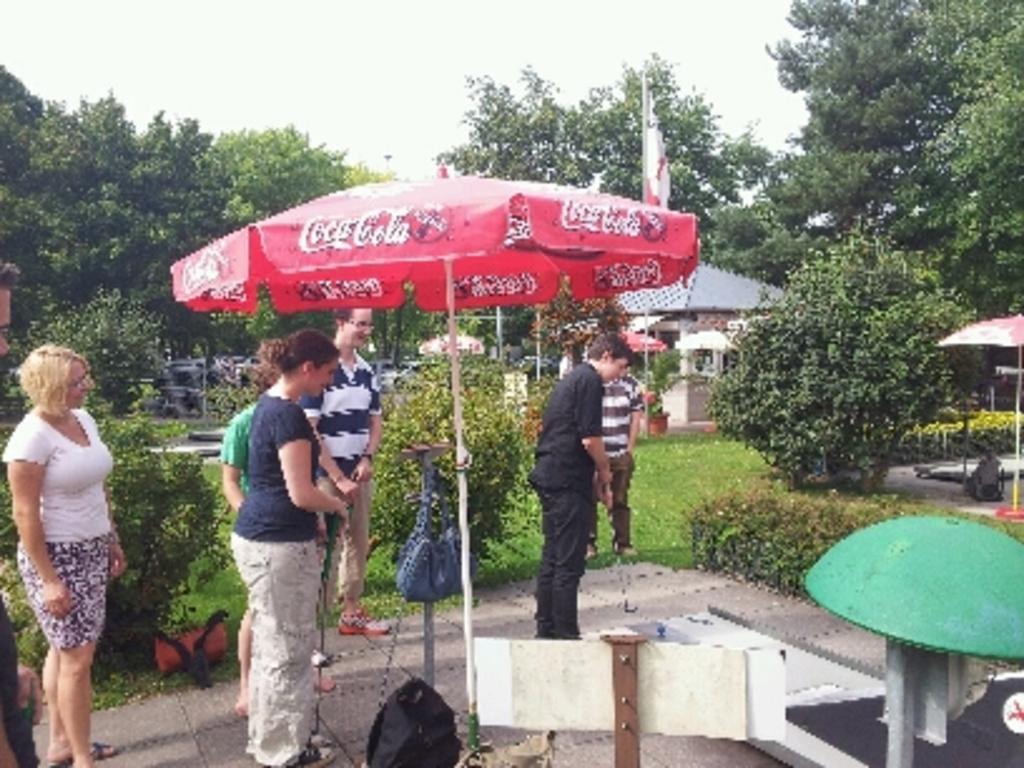Describe this image in one or two sentences. This picture consists of red color tent , under the tent I can see few persons and pole and bag attached to the pole and a luggage bag kept on floor at the bottom and I can see there are remaining persons standing in front of plants and trees and houses visible in the middle. in the background there are some vehicle and at the top I can see the sky and on the right side I can see tents 